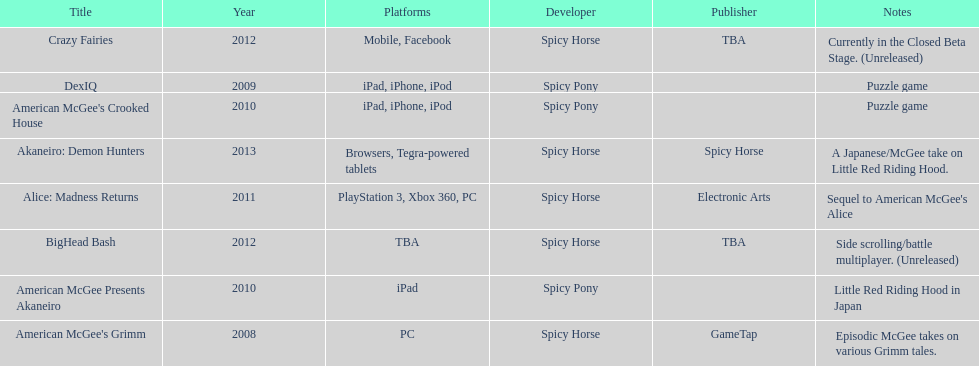How many games did spicy horse develop in total? 5. 